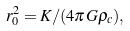Convert formula to latex. <formula><loc_0><loc_0><loc_500><loc_500>r _ { 0 } ^ { 2 } = K / ( 4 \pi G \rho _ { c } ) ,</formula> 